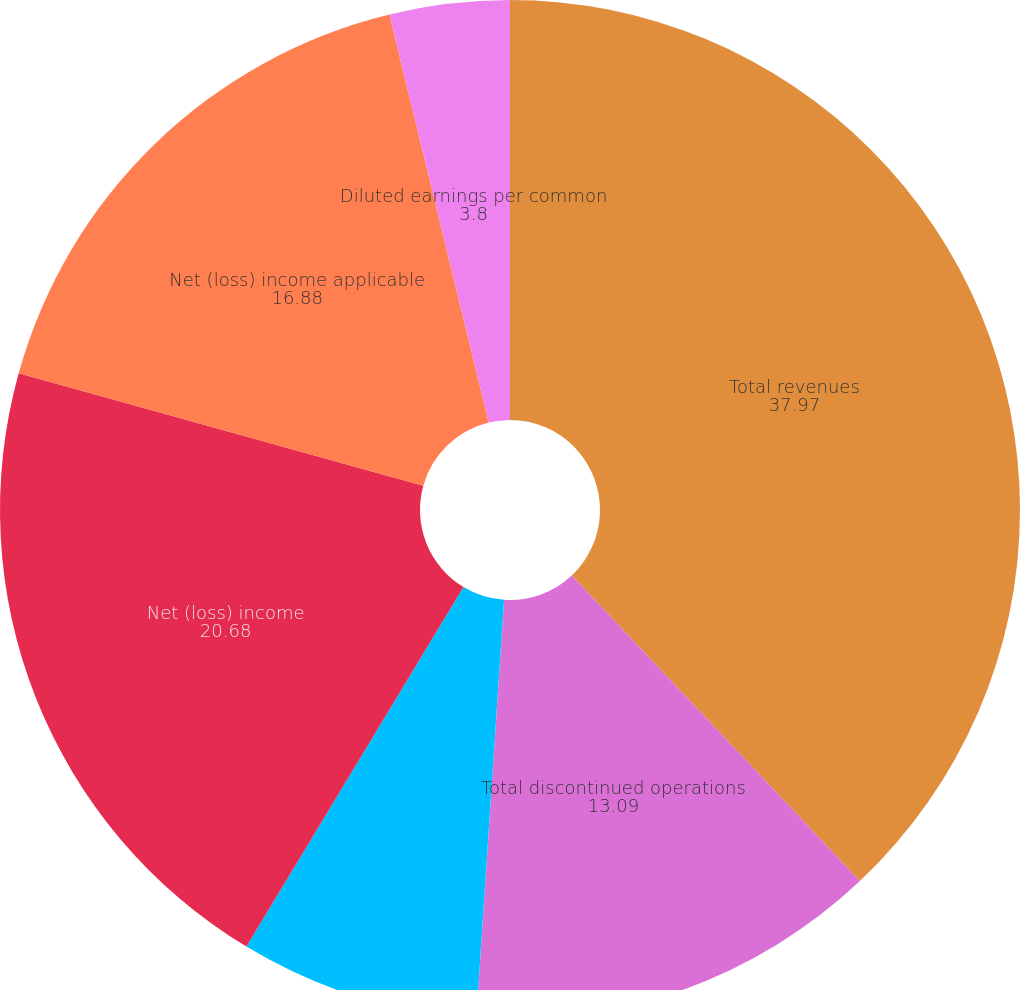Convert chart to OTSL. <chart><loc_0><loc_0><loc_500><loc_500><pie_chart><fcel>Total revenues<fcel>Total discontinued operations<fcel>Income (loss) before income<fcel>Net (loss) income<fcel>Net (loss) income applicable<fcel>Basic earnings per common<fcel>Diluted earnings per common<nl><fcel>37.97%<fcel>13.09%<fcel>7.59%<fcel>20.68%<fcel>16.88%<fcel>0.0%<fcel>3.8%<nl></chart> 